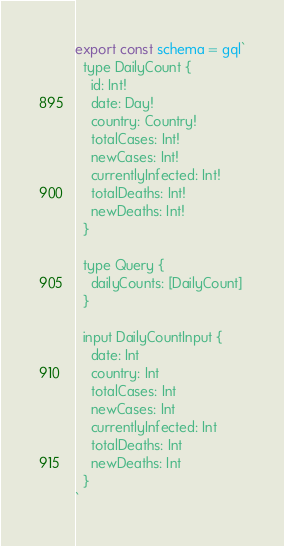Convert code to text. <code><loc_0><loc_0><loc_500><loc_500><_JavaScript_>export const schema = gql`
  type DailyCount {
    id: Int!
    date: Day!
    country: Country!
    totalCases: Int!
    newCases: Int!
    currentlyInfected: Int!
    totalDeaths: Int!
    newDeaths: Int!
  }

  type Query {
    dailyCounts: [DailyCount]
  }

  input DailyCountInput {
    date: Int
    country: Int
    totalCases: Int
    newCases: Int
    currentlyInfected: Int
    totalDeaths: Int
    newDeaths: Int
  }
`
</code> 